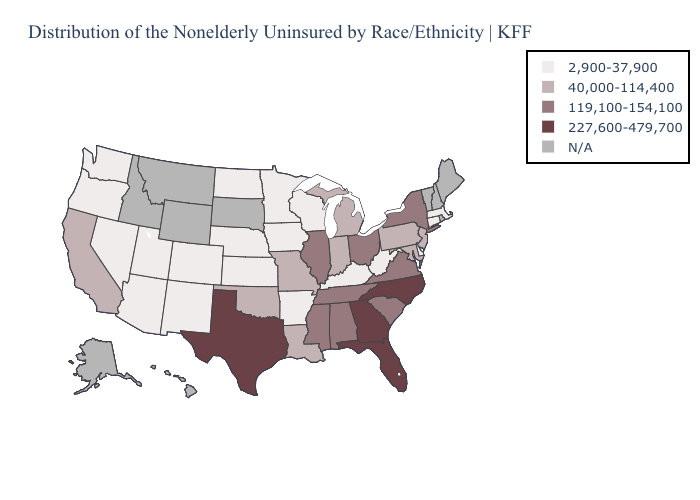Name the states that have a value in the range N/A?
Quick response, please. Alaska, Hawaii, Idaho, Maine, Montana, New Hampshire, Rhode Island, South Dakota, Vermont, Wyoming. Which states hav the highest value in the South?
Quick response, please. Florida, Georgia, North Carolina, Texas. Which states have the lowest value in the South?
Be succinct. Arkansas, Delaware, Kentucky, West Virginia. Among the states that border Wyoming , which have the highest value?
Quick response, please. Colorado, Nebraska, Utah. What is the highest value in states that border North Dakota?
Answer briefly. 2,900-37,900. Name the states that have a value in the range 227,600-479,700?
Short answer required. Florida, Georgia, North Carolina, Texas. What is the value of Missouri?
Keep it brief. 40,000-114,400. Which states have the lowest value in the MidWest?
Keep it brief. Iowa, Kansas, Minnesota, Nebraska, North Dakota, Wisconsin. Among the states that border Indiana , does Michigan have the highest value?
Write a very short answer. No. Name the states that have a value in the range 40,000-114,400?
Quick response, please. California, Indiana, Louisiana, Maryland, Michigan, Missouri, New Jersey, Oklahoma, Pennsylvania. Name the states that have a value in the range 119,100-154,100?
Short answer required. Alabama, Illinois, Mississippi, New York, Ohio, South Carolina, Tennessee, Virginia. What is the value of Idaho?
Concise answer only. N/A. Which states have the highest value in the USA?
Concise answer only. Florida, Georgia, North Carolina, Texas. Name the states that have a value in the range 40,000-114,400?
Quick response, please. California, Indiana, Louisiana, Maryland, Michigan, Missouri, New Jersey, Oklahoma, Pennsylvania. 